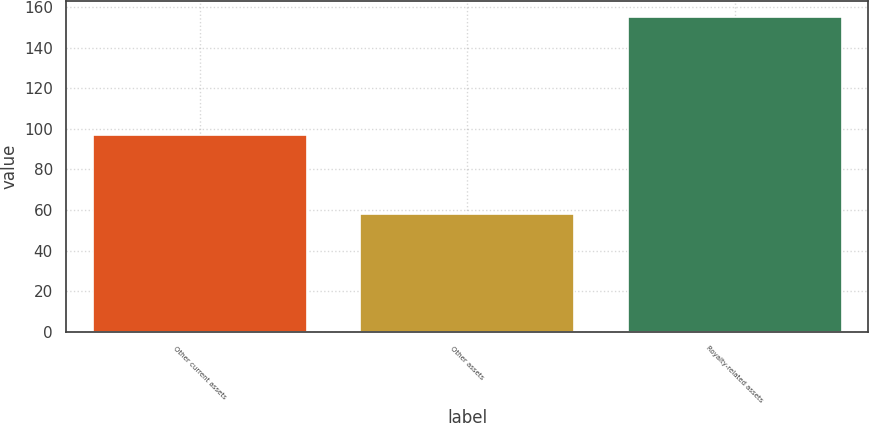Convert chart. <chart><loc_0><loc_0><loc_500><loc_500><bar_chart><fcel>Other current assets<fcel>Other assets<fcel>Royalty-related assets<nl><fcel>97<fcel>58<fcel>155<nl></chart> 